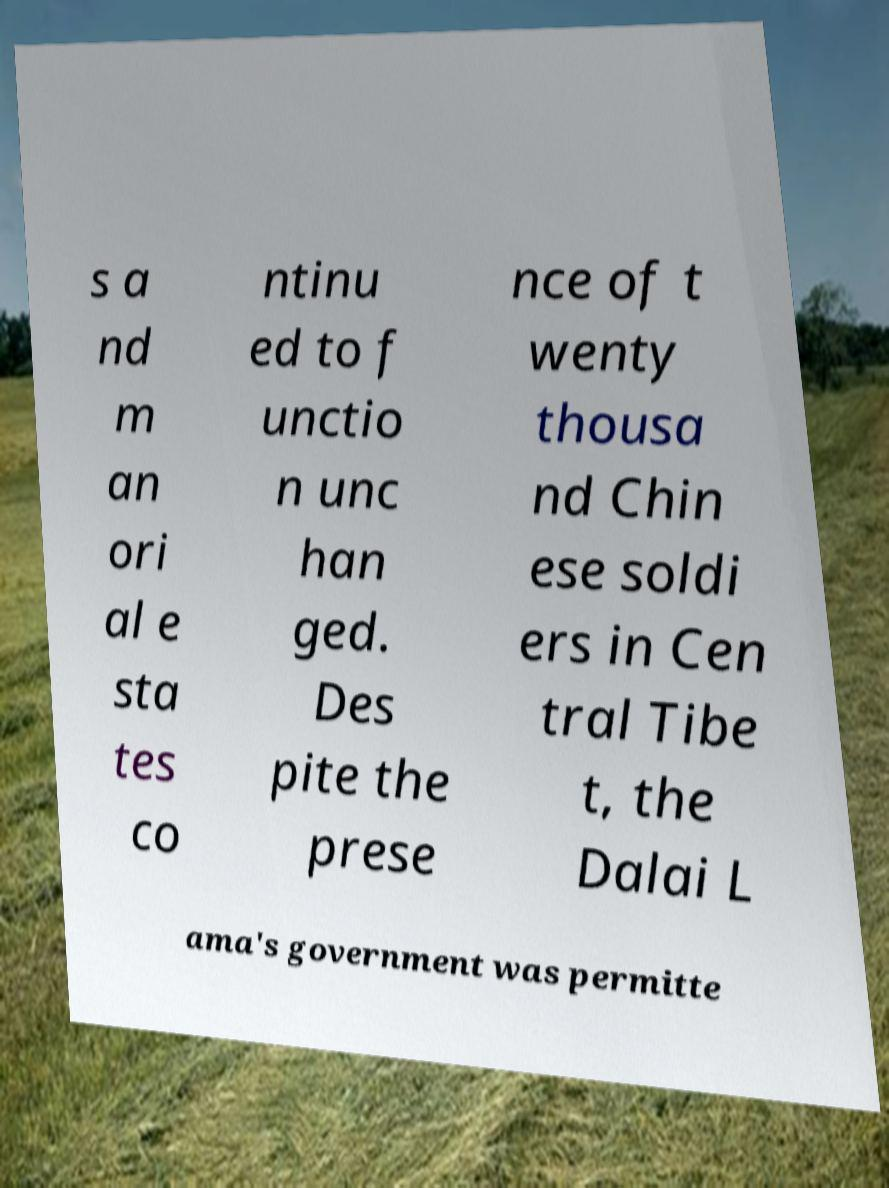Could you assist in decoding the text presented in this image and type it out clearly? s a nd m an ori al e sta tes co ntinu ed to f unctio n unc han ged. Des pite the prese nce of t wenty thousa nd Chin ese soldi ers in Cen tral Tibe t, the Dalai L ama's government was permitte 